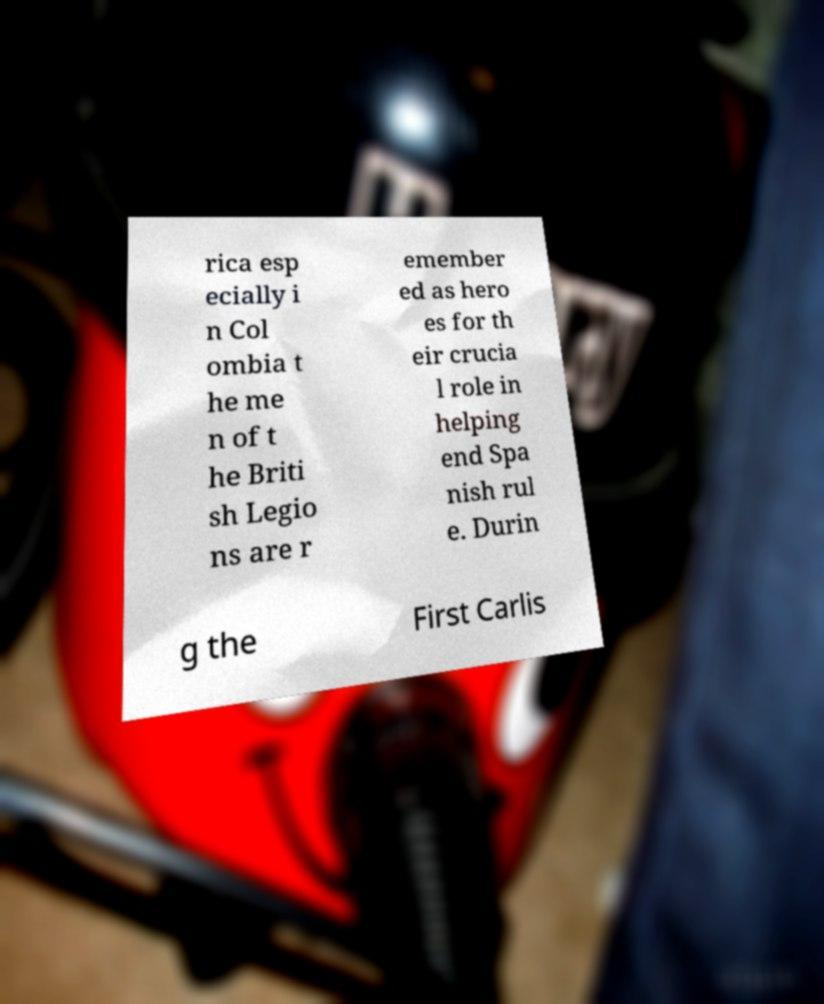Could you assist in decoding the text presented in this image and type it out clearly? rica esp ecially i n Col ombia t he me n of t he Briti sh Legio ns are r emember ed as hero es for th eir crucia l role in helping end Spa nish rul e. Durin g the First Carlis 